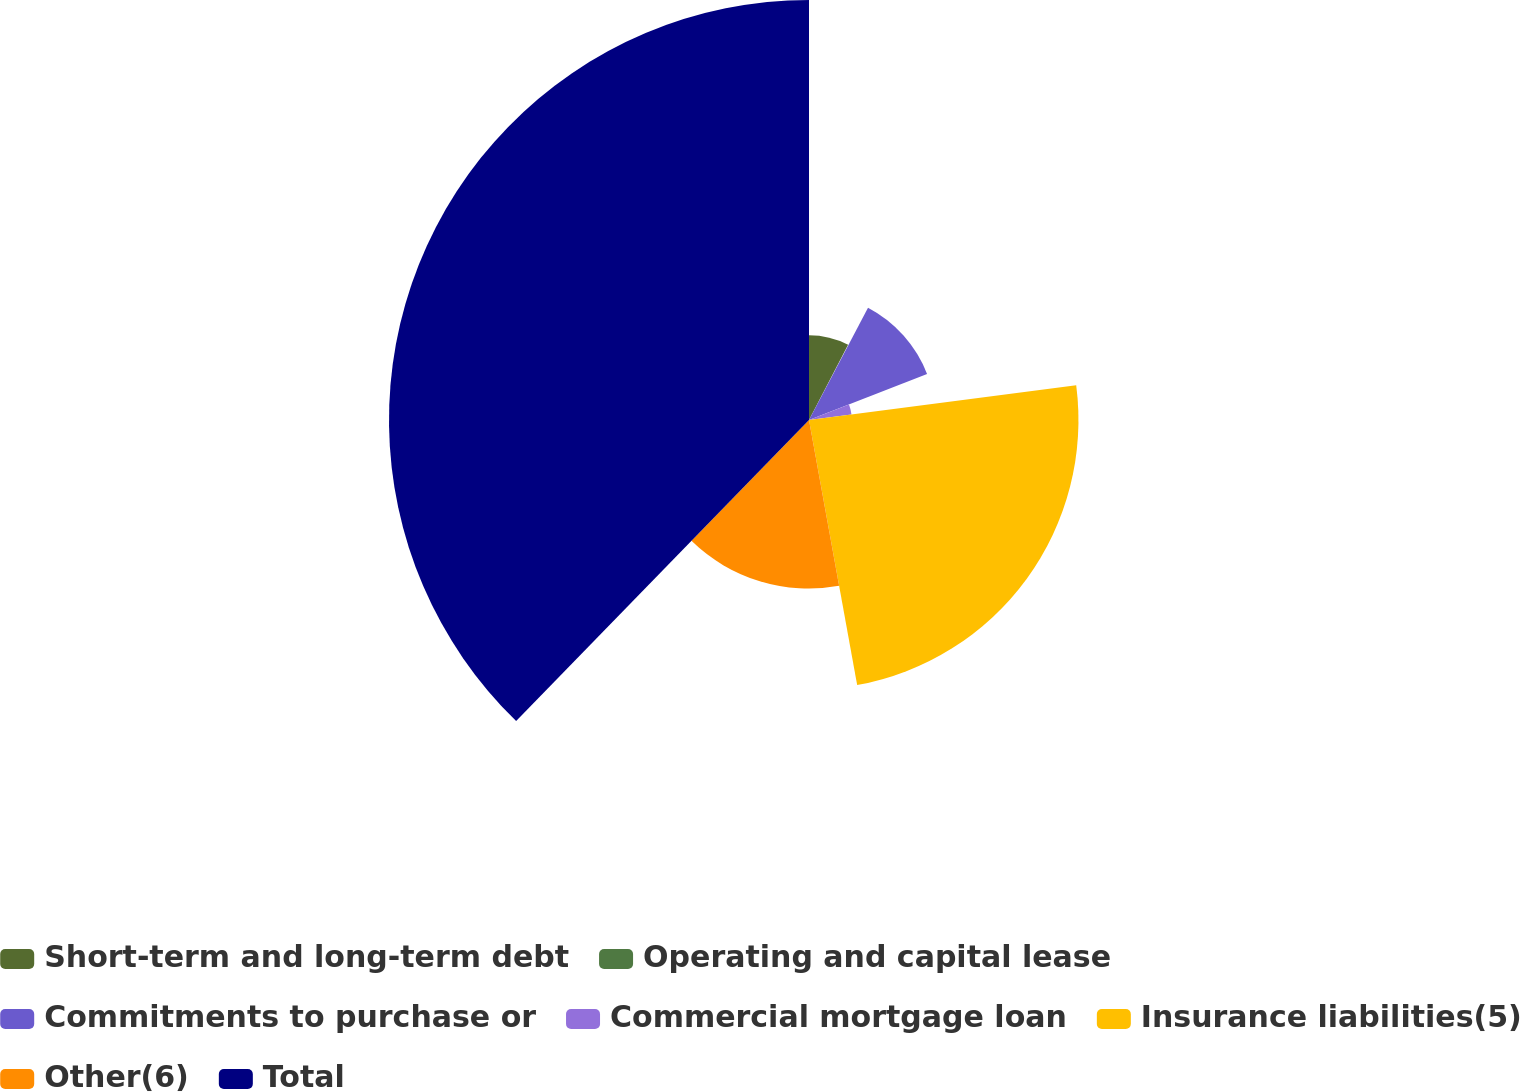<chart> <loc_0><loc_0><loc_500><loc_500><pie_chart><fcel>Short-term and long-term debt<fcel>Operating and capital lease<fcel>Commitments to purchase or<fcel>Commercial mortgage loan<fcel>Insurance liabilities(5)<fcel>Other(6)<fcel>Total<nl><fcel>7.62%<fcel>0.09%<fcel>11.38%<fcel>3.85%<fcel>24.2%<fcel>15.14%<fcel>37.72%<nl></chart> 